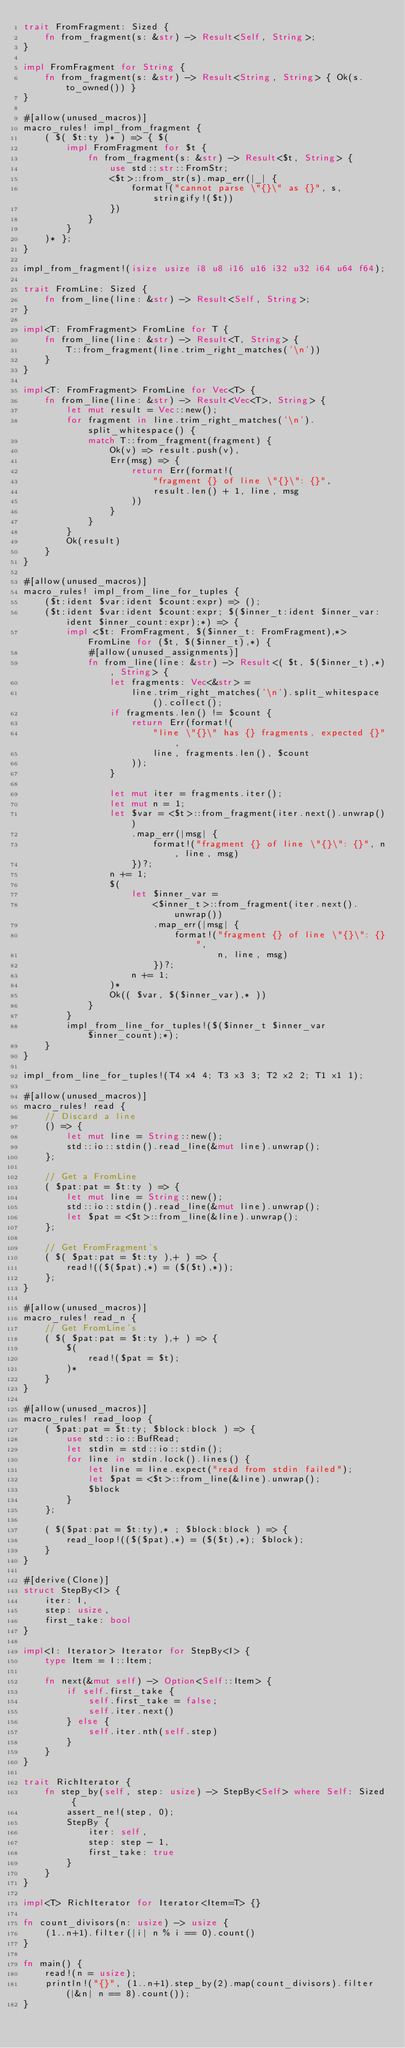<code> <loc_0><loc_0><loc_500><loc_500><_Rust_>trait FromFragment: Sized {
    fn from_fragment(s: &str) -> Result<Self, String>;
}

impl FromFragment for String {
    fn from_fragment(s: &str) -> Result<String, String> { Ok(s.to_owned()) }
}

#[allow(unused_macros)]
macro_rules! impl_from_fragment {
    ( $( $t:ty )* ) => { $(
        impl FromFragment for $t {
            fn from_fragment(s: &str) -> Result<$t, String> {
                use std::str::FromStr;
                <$t>::from_str(s).map_err(|_| {
                    format!("cannot parse \"{}\" as {}", s, stringify!($t))
                })
            }
        }
    )* };
}

impl_from_fragment!(isize usize i8 u8 i16 u16 i32 u32 i64 u64 f64);

trait FromLine: Sized {
    fn from_line(line: &str) -> Result<Self, String>;
}

impl<T: FromFragment> FromLine for T {
    fn from_line(line: &str) -> Result<T, String> {
        T::from_fragment(line.trim_right_matches('\n'))
    }
}

impl<T: FromFragment> FromLine for Vec<T> {
    fn from_line(line: &str) -> Result<Vec<T>, String> {
        let mut result = Vec::new();
        for fragment in line.trim_right_matches('\n').split_whitespace() {
            match T::from_fragment(fragment) {
                Ok(v) => result.push(v),
                Err(msg) => {
                    return Err(format!(
                        "fragment {} of line \"{}\": {}",
                        result.len() + 1, line, msg
                    ))
                }
            }
        }
        Ok(result)
    }
}

#[allow(unused_macros)]
macro_rules! impl_from_line_for_tuples {
    ($t:ident $var:ident $count:expr) => ();
    ($t:ident $var:ident $count:expr; $($inner_t:ident $inner_var:ident $inner_count:expr);*) => {
        impl <$t: FromFragment, $($inner_t: FromFragment),*> FromLine for ($t, $($inner_t),*) {
            #[allow(unused_assignments)]
            fn from_line(line: &str) -> Result<( $t, $($inner_t),*), String> {
                let fragments: Vec<&str> =
                    line.trim_right_matches('\n').split_whitespace().collect();
                if fragments.len() != $count {
                    return Err(format!(
                        "line \"{}\" has {} fragments, expected {}",
                        line, fragments.len(), $count
                    ));
                }

                let mut iter = fragments.iter();
                let mut n = 1;
                let $var = <$t>::from_fragment(iter.next().unwrap())
                    .map_err(|msg| {
                        format!("fragment {} of line \"{}\": {}", n, line, msg)
                    })?;
                n += 1;
                $(
                    let $inner_var =
                        <$inner_t>::from_fragment(iter.next().unwrap())
                        .map_err(|msg| {
                            format!("fragment {} of line \"{}\": {}",
                                    n, line, msg)
                        })?;
                    n += 1;
                )*
                Ok(( $var, $($inner_var),* ))
            }
        }
        impl_from_line_for_tuples!($($inner_t $inner_var $inner_count);*);
    }
}

impl_from_line_for_tuples!(T4 x4 4; T3 x3 3; T2 x2 2; T1 x1 1);

#[allow(unused_macros)]
macro_rules! read {
    // Discard a line
    () => {
        let mut line = String::new();
        std::io::stdin().read_line(&mut line).unwrap();
    };

    // Get a FromLine
    ( $pat:pat = $t:ty ) => {
        let mut line = String::new();
        std::io::stdin().read_line(&mut line).unwrap();
        let $pat = <$t>::from_line(&line).unwrap();
    };

    // Get FromFragment's
    ( $( $pat:pat = $t:ty ),+ ) => {
        read!(($($pat),*) = ($($t),*));
    };
}

#[allow(unused_macros)]
macro_rules! read_n {
    // Get FromLine's
    ( $( $pat:pat = $t:ty ),+ ) => {
        $(
            read!($pat = $t);
        )*
    }
}

#[allow(unused_macros)]
macro_rules! read_loop {
    ( $pat:pat = $t:ty; $block:block ) => {
        use std::io::BufRead;
        let stdin = std::io::stdin();
        for line in stdin.lock().lines() {
            let line = line.expect("read from stdin failed");
            let $pat = <$t>::from_line(&line).unwrap();
            $block
        }
    };

    ( $($pat:pat = $t:ty),* ; $block:block ) => {
        read_loop!(($($pat),*) = ($($t),*); $block);
    }
}

#[derive(Clone)]
struct StepBy<I> {
    iter: I,
    step: usize,
    first_take: bool
}

impl<I: Iterator> Iterator for StepBy<I> {
    type Item = I::Item;

    fn next(&mut self) -> Option<Self::Item> {
        if self.first_take {
            self.first_take = false;
            self.iter.next()
        } else {
            self.iter.nth(self.step)
        }
    }
}

trait RichIterator {
    fn step_by(self, step: usize) -> StepBy<Self> where Self: Sized {
        assert_ne!(step, 0);
        StepBy {
            iter: self,
            step: step - 1,
            first_take: true
        }
    }
}

impl<T> RichIterator for Iterator<Item=T> {}

fn count_divisors(n: usize) -> usize {
    (1..n+1).filter(|i| n % i == 0).count()
}

fn main() {
    read!(n = usize);
    println!("{}", (1..n+1).step_by(2).map(count_divisors).filter(|&n| n == 8).count());
}
</code> 